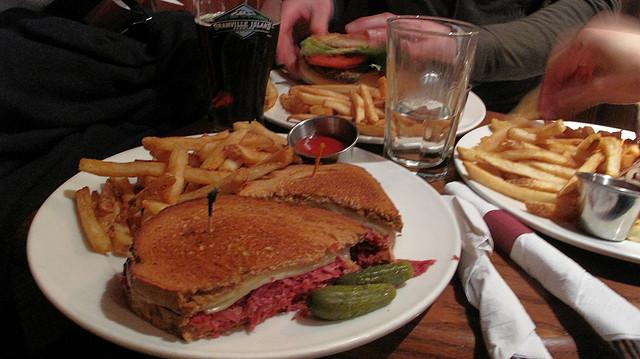Is the water glass empty?
Quick response, please. Yes. What are sticking into the sandwiches?
Keep it brief. Toothpicks. What is the meat on the sandwich?
Give a very brief answer. Corned beef. What food is this?
Keep it brief. Sandwich. What is red?
Short answer required. Ketchup. How many plates of fries are there?
Concise answer only. 3. 